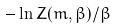<formula> <loc_0><loc_0><loc_500><loc_500>- \ln Z ( m , \beta ) / \beta</formula> 